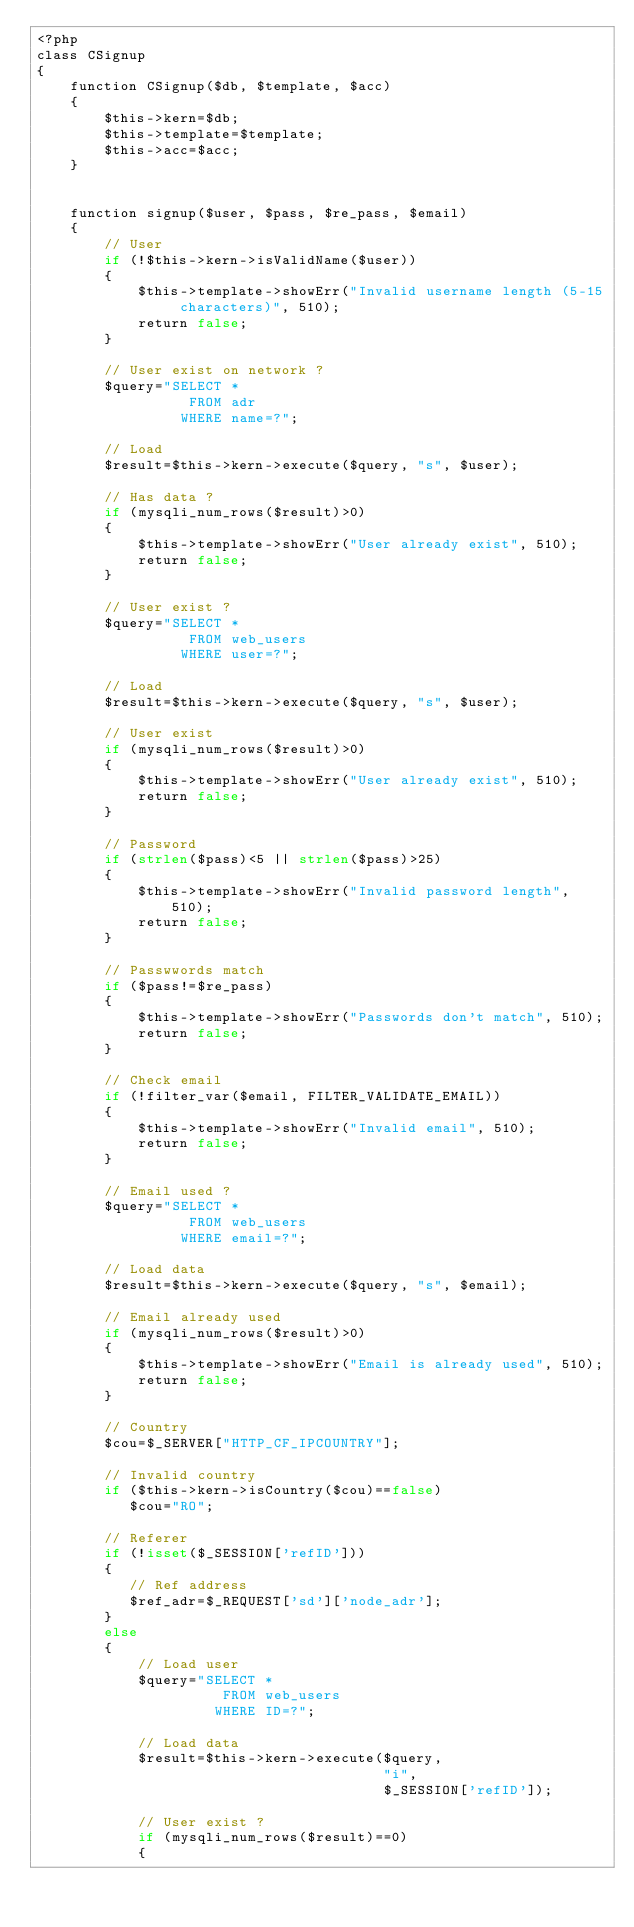<code> <loc_0><loc_0><loc_500><loc_500><_PHP_><?php
class CSignup
{
	function CSignup($db, $template, $acc)
	{
		$this->kern=$db;
		$this->template=$template;
		$this->acc=$acc;
	}
	
	
	function signup($user, $pass, $re_pass, $email)
	{
		// User
		if (!$this->kern->isValidName($user))
		{
			$this->template->showErr("Invalid username length (5-15 characters)", 510);
			return false;
		}
		
		// User exist on network ?
		$query="SELECT * 
		          FROM adr 
				 WHERE name=?";
		
		// Load
		$result=$this->kern->execute($query, "s", $user);
		
		// Has data ?
		if (mysqli_num_rows($result)>0)
		{
			$this->template->showErr("User already exist", 510);
			return false;
		}
		
		// User exist ?
		$query="SELECT * 
		          FROM web_users 
				 WHERE user=?";
		
		// Load
		$result=$this->kern->execute($query, "s", $user);
		
		// User exist
		if (mysqli_num_rows($result)>0)
		{
			$this->template->showErr("User already exist", 510);
			return false;
		}
		
		// Password
		if (strlen($pass)<5 || strlen($pass)>25)
		{
			$this->template->showErr("Invalid password length", 510);
			return false;
		}
		
		// Passwwords match
		if ($pass!=$re_pass)
		{
			$this->template->showErr("Passwords don't match", 510);
			return false;
		}
		
		// Check email
		if (!filter_var($email, FILTER_VALIDATE_EMAIL)) 
		{
			$this->template->showErr("Invalid email", 510);
			return false;
		}
		
		// Email used ?
		$query="SELECT * 
		          FROM web_users 
				 WHERE email=?";
				 
		// Load data
		$result=$this->kern->execute($query, "s", $email);
		
		// Email already used
		if (mysqli_num_rows($result)>0)
		{
			$this->template->showErr("Email is already used", 510);
			return false;
		}
		
		// Country
		$cou=$_SERVER["HTTP_CF_IPCOUNTRY"];
		 
		// Invalid country
		if ($this->kern->isCountry($cou)==false)
		   $cou="RO"; 
		   
		// Referer
		if (!isset($_SESSION['refID']))
		{
		   // Ref address
		   $ref_adr=$_REQUEST['sd']['node_adr']; 
		}
		else
		{
			// Load user
			$query="SELECT * 
			          FROM web_users 
					 WHERE ID=?";
			
			// Load data
		    $result=$this->kern->execute($query, 
										 "i", 
										 $_SESSION['refID']);
			
			// User exist ?
			if (mysqli_num_rows($result)==0)
			{</code> 